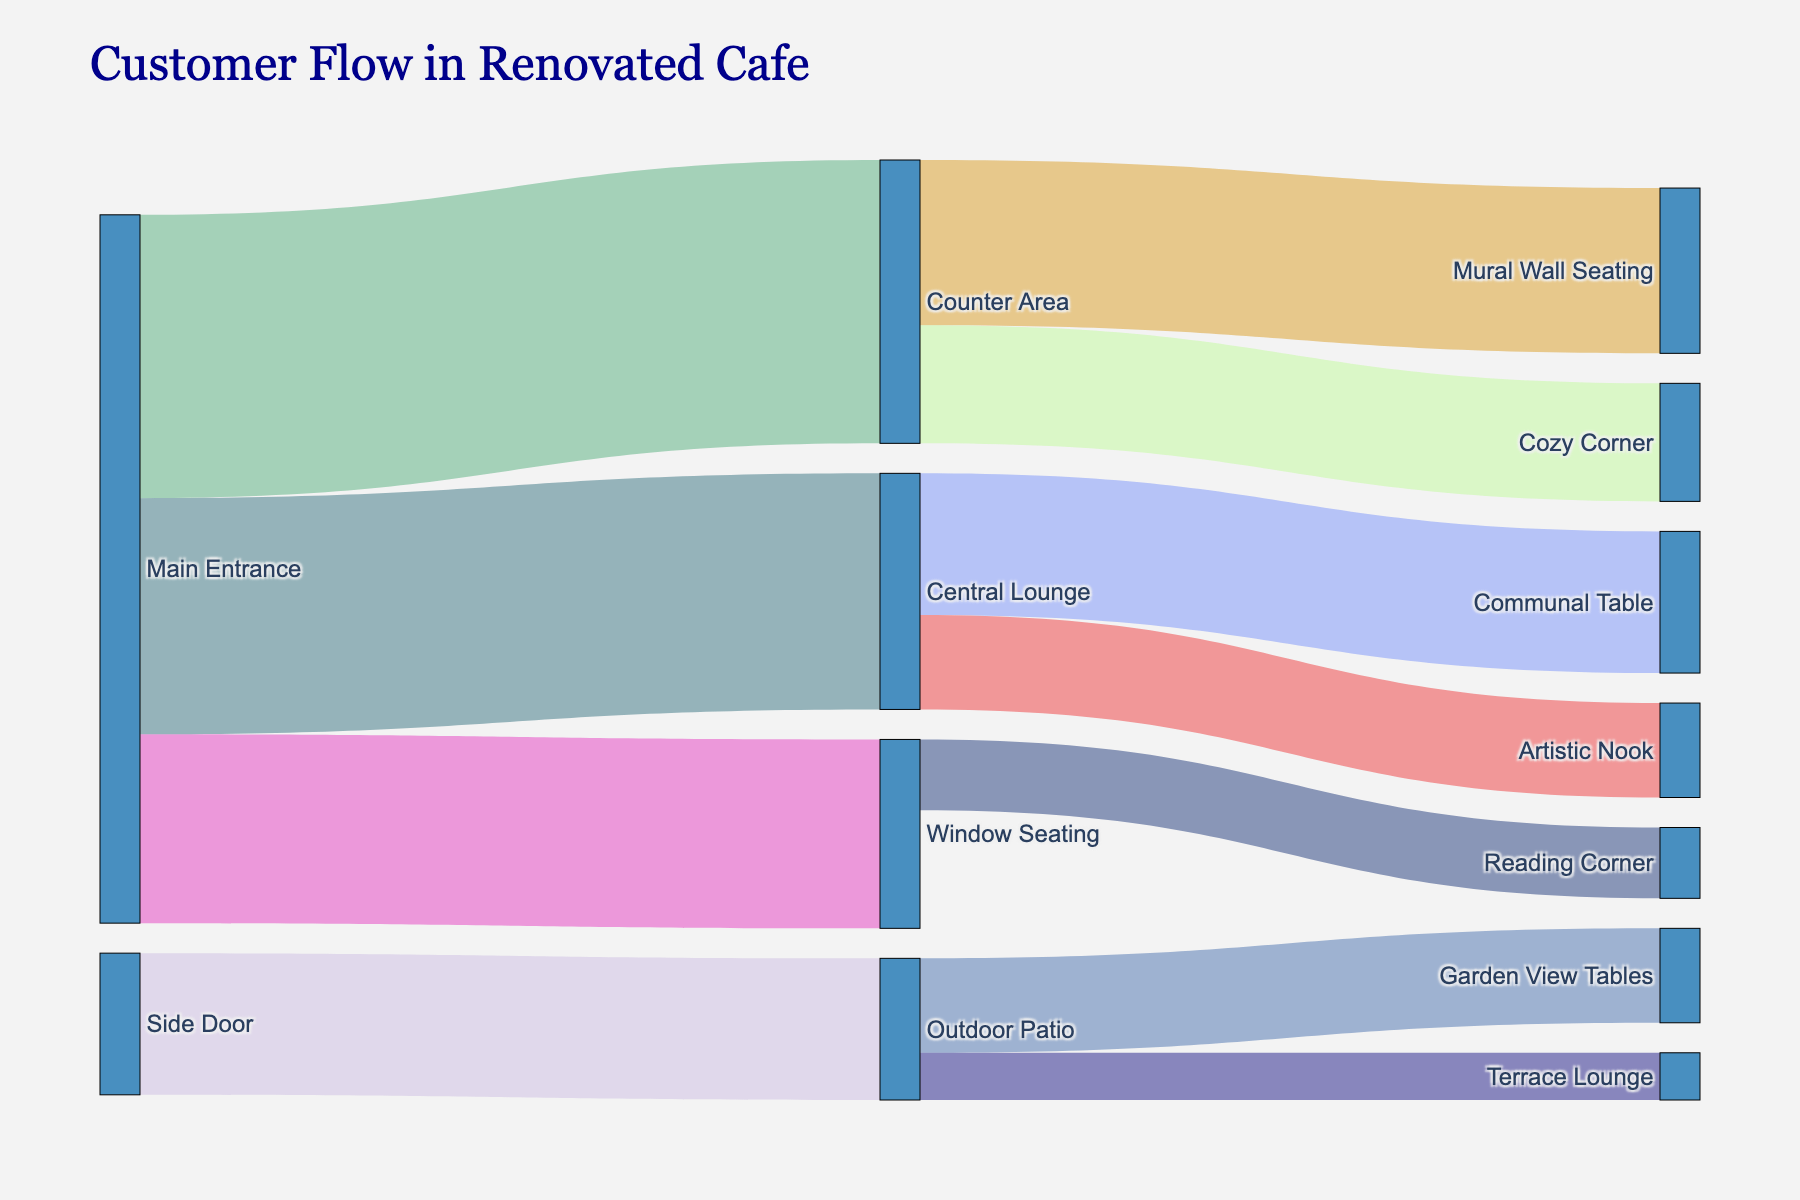What's the title of the Sankey diagram? The title of the diagram can be found at the top of the figure, typically in larger font than other text elements.
Answer: _Customer Flow in Renovated Cafe_ What are the main entry points for customers in the cafe? Look at the outermost nodes on the left side of the diagram. These are typically the starting points or sources of the flow.
Answer: _Main Entrance, Side Door_ Which entry point has the highest foot traffic? Compare the values associated with the links originating from each entry point. The one with the highest total value has the highest foot traffic.
Answer: _Main Entrance_ How many customers move from the Central Lounge to the Artistic Nook? Identify the flow link originating from the Central Lounge and terminating at the Artistic Nook and read its value.
Answer: _40_ Which area receives foot traffic directly from the Counter Area? Trace the flow links starting from the Counter Area to their target nodes.
Answer: _Mural Wall Seating, Cozy Corner_ What's the total customer count entering from the Side Door? Look at the value of the flow link starting from the Side Door and sum them if there is more than one. In this case, there is one flow, so this value is the total count.
Answer: _60_ What percentage of customers entering via Main Entrance goes to the Central Lounge? First, sum the total values of all links originating from Main Entrance. Then divide the value of the link to the Central Lounge by this total and multiply by 100. (100 / (120 + 80 + 100)) * 100
Answer: _31.25%_ Which seating area receives the least traffic from the Counter Area? Compare the values of links originating from the Counter Area and identify the smallest value.
Answer: _Cozy Corner_ Are there more customers at Garden View Tables or Terrace Lounge? Compare the values of links ending at each of these areas.
Answer: _Garden View Tables_ What is the total number of customers utilizing the Counter Area for their first stop? Sum the values of all flow links originating from the Main Entrance and leading to Counter Area.
Answer: _120_ 